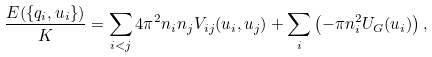<formula> <loc_0><loc_0><loc_500><loc_500>\frac { E ( \{ q _ { i } , u _ { i } \} ) } { K } = \sum _ { i < j } 4 \pi ^ { 2 } n _ { i } n _ { j } V _ { i j } ( { u } _ { i } , { u } _ { j } ) + \sum _ { i } \left ( - \pi n _ { i } ^ { 2 } U _ { G } ( { u } _ { i } ) \right ) ,</formula> 